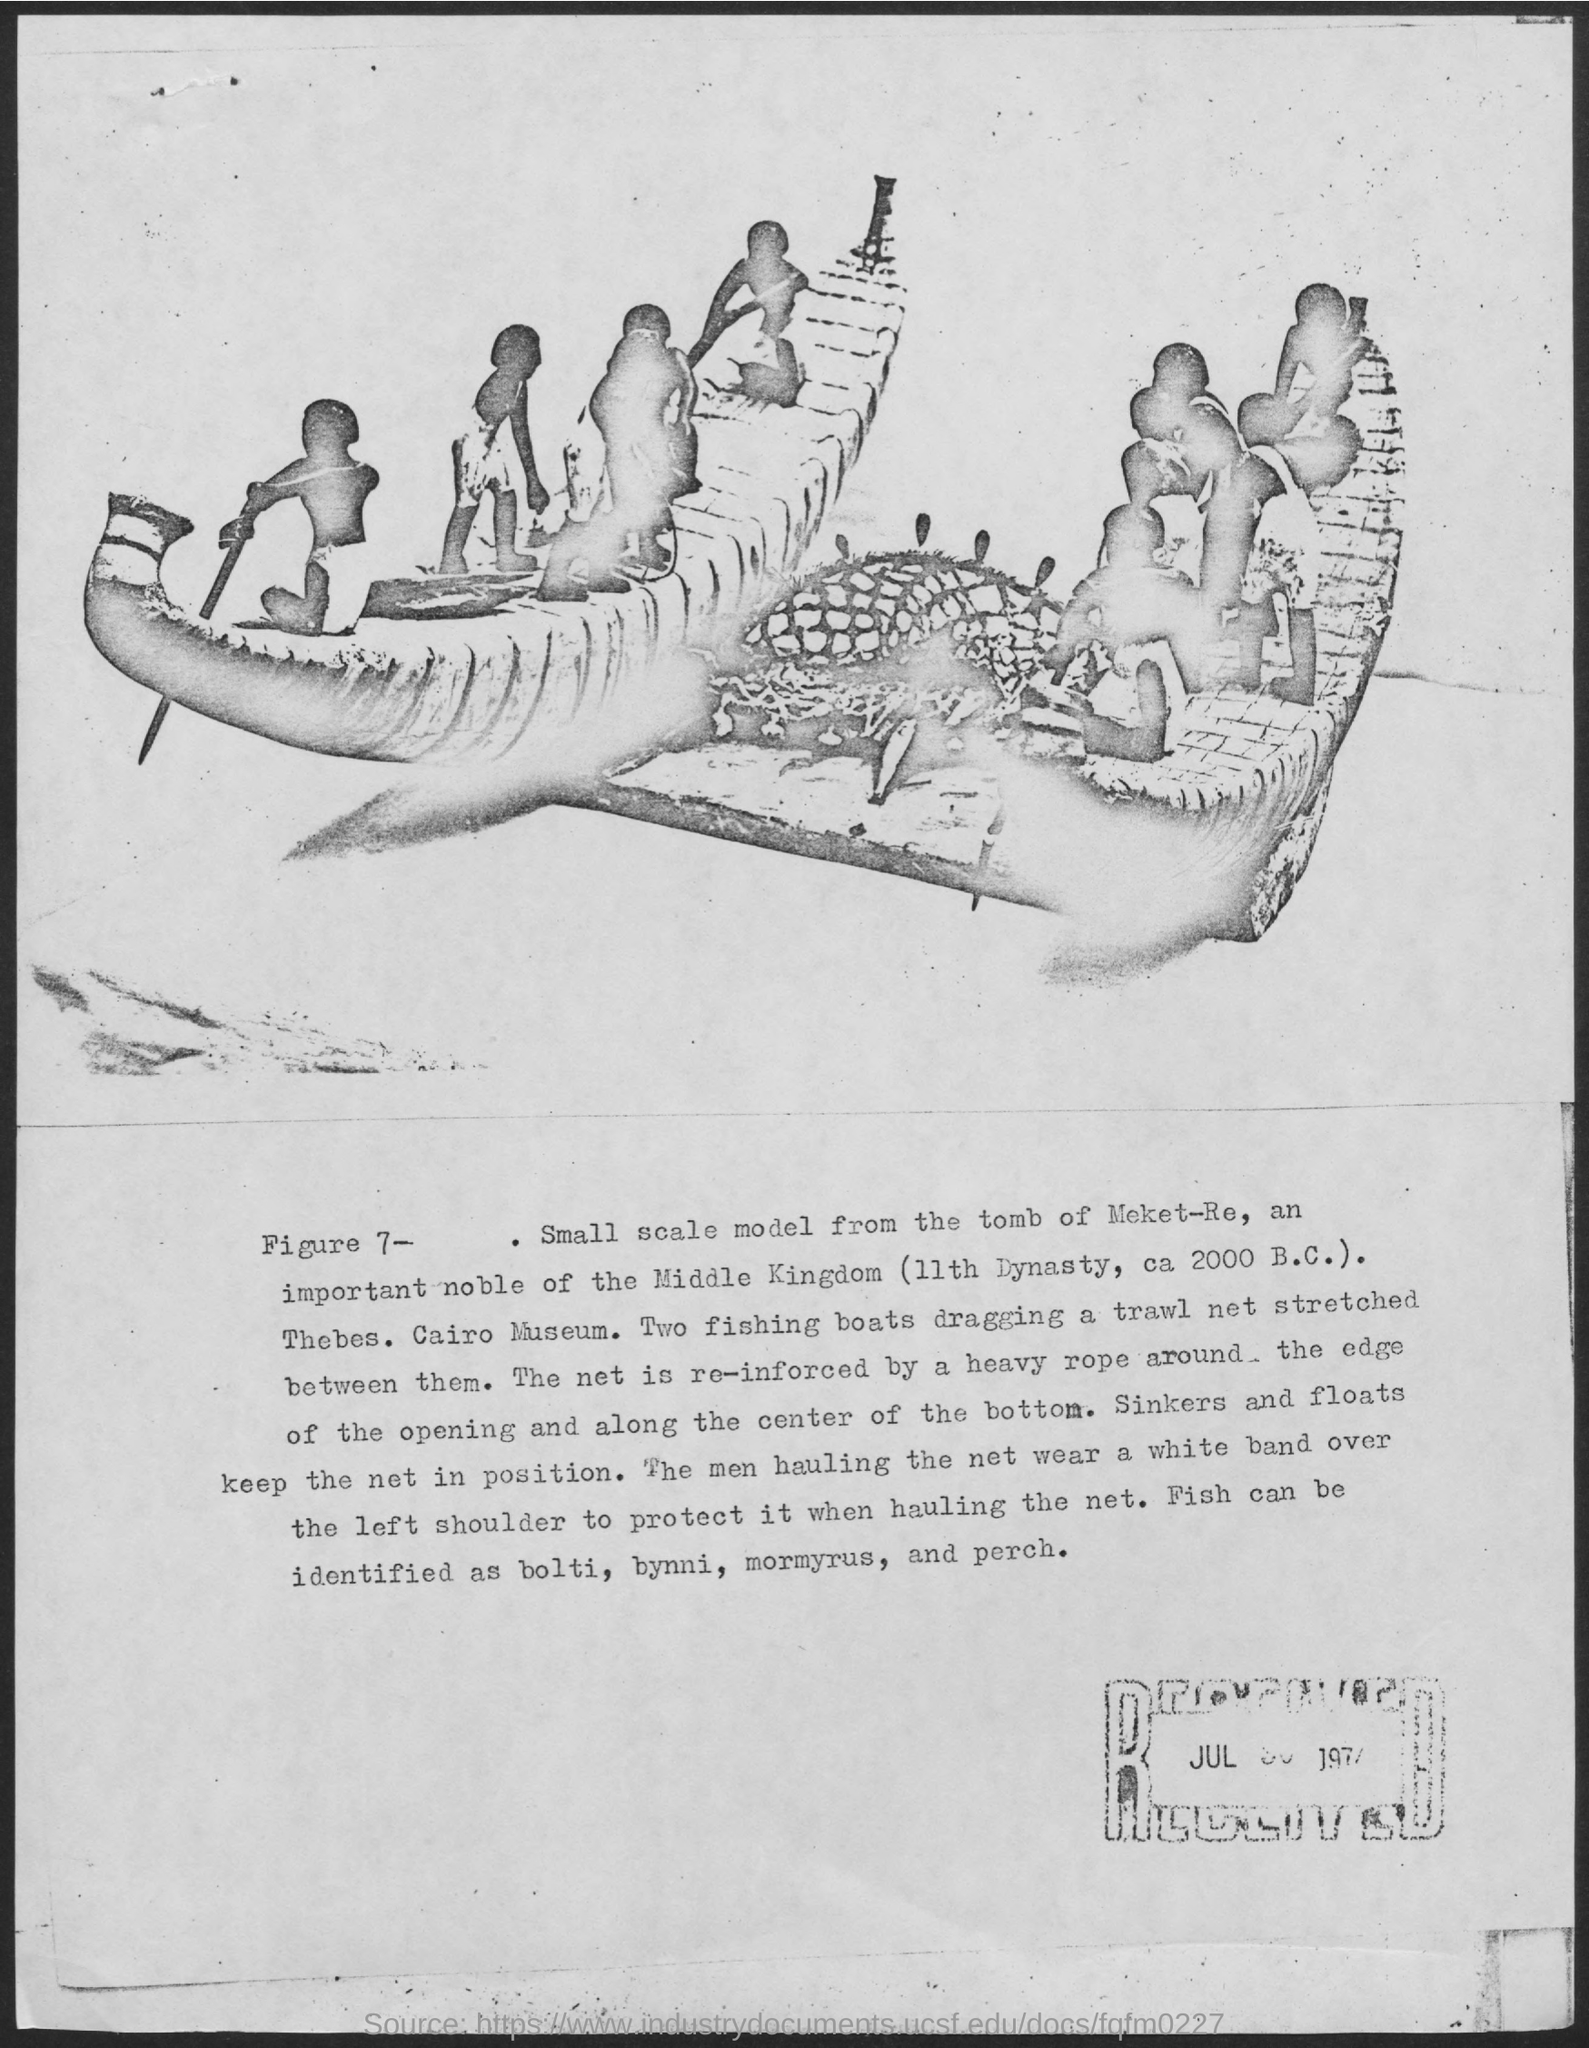What can you infer about the society that created this artifact? This artifact suggests that the society from the Middle Kingdom of Egypt placed a significant value on fishing as an economic activity. The detailed craftsmanship of the model indicates the importance of fish and fishing in their daily life and diet, and the inclusion in a tomb suggests that it might also have religious or afterlife significance, ensuring the deceased continued to have provisions in the next world. 